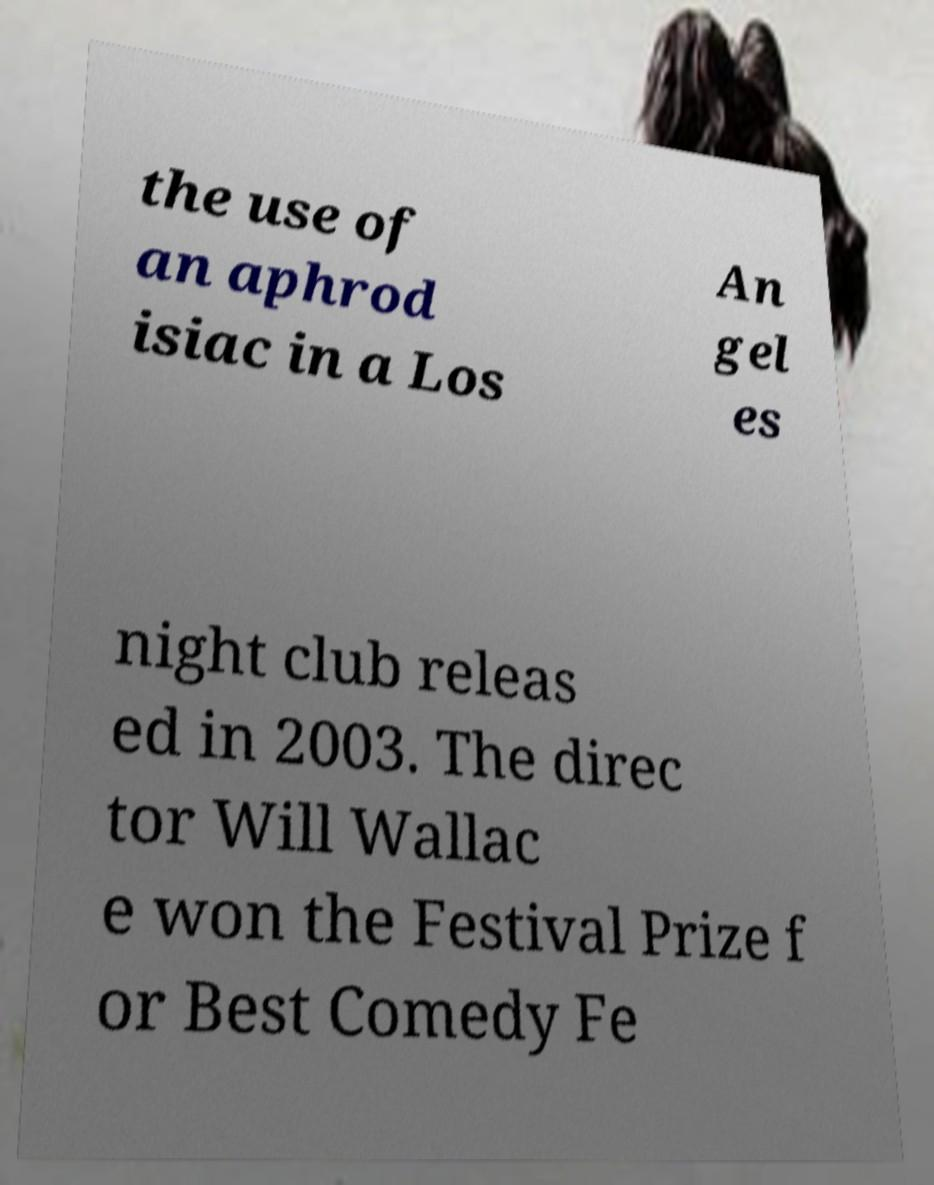Could you extract and type out the text from this image? the use of an aphrod isiac in a Los An gel es night club releas ed in 2003. The direc tor Will Wallac e won the Festival Prize f or Best Comedy Fe 